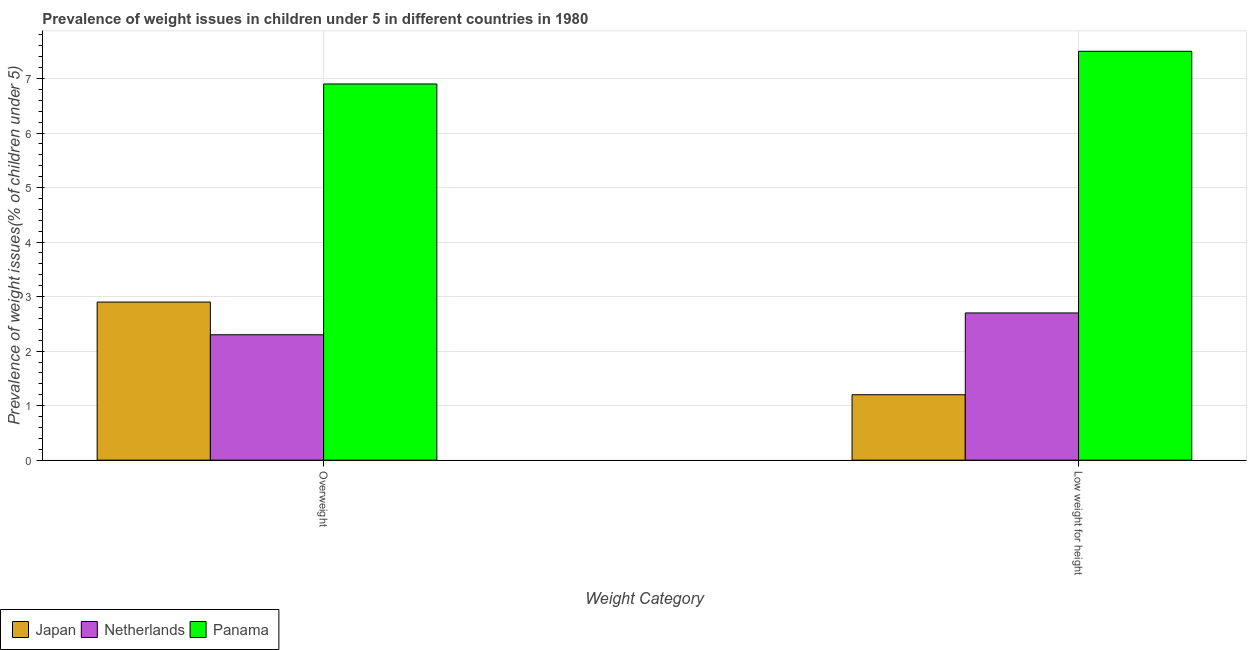Are the number of bars per tick equal to the number of legend labels?
Offer a very short reply. Yes. Are the number of bars on each tick of the X-axis equal?
Ensure brevity in your answer.  Yes. How many bars are there on the 1st tick from the right?
Provide a short and direct response. 3. What is the label of the 2nd group of bars from the left?
Offer a very short reply. Low weight for height. What is the percentage of underweight children in Japan?
Your response must be concise. 1.2. Across all countries, what is the maximum percentage of underweight children?
Keep it short and to the point. 7.5. Across all countries, what is the minimum percentage of overweight children?
Your answer should be compact. 2.3. In which country was the percentage of overweight children maximum?
Offer a very short reply. Panama. What is the total percentage of underweight children in the graph?
Ensure brevity in your answer.  11.4. What is the difference between the percentage of overweight children in Netherlands and that in Japan?
Ensure brevity in your answer.  -0.6. What is the difference between the percentage of underweight children in Japan and the percentage of overweight children in Panama?
Provide a short and direct response. -5.7. What is the average percentage of underweight children per country?
Provide a short and direct response. 3.8. What is the difference between the percentage of overweight children and percentage of underweight children in Panama?
Make the answer very short. -0.6. In how many countries, is the percentage of overweight children greater than 3.4 %?
Provide a succinct answer. 1. What is the ratio of the percentage of underweight children in Japan to that in Netherlands?
Ensure brevity in your answer.  0.44. What does the 3rd bar from the left in Low weight for height represents?
Your response must be concise. Panama. What does the 3rd bar from the right in Low weight for height represents?
Offer a terse response. Japan. How many bars are there?
Your answer should be compact. 6. Does the graph contain any zero values?
Ensure brevity in your answer.  No. Does the graph contain grids?
Offer a terse response. Yes. Where does the legend appear in the graph?
Keep it short and to the point. Bottom left. How many legend labels are there?
Offer a terse response. 3. What is the title of the graph?
Provide a short and direct response. Prevalence of weight issues in children under 5 in different countries in 1980. Does "Solomon Islands" appear as one of the legend labels in the graph?
Ensure brevity in your answer.  No. What is the label or title of the X-axis?
Give a very brief answer. Weight Category. What is the label or title of the Y-axis?
Provide a succinct answer. Prevalence of weight issues(% of children under 5). What is the Prevalence of weight issues(% of children under 5) in Japan in Overweight?
Offer a very short reply. 2.9. What is the Prevalence of weight issues(% of children under 5) in Netherlands in Overweight?
Your answer should be very brief. 2.3. What is the Prevalence of weight issues(% of children under 5) in Panama in Overweight?
Your response must be concise. 6.9. What is the Prevalence of weight issues(% of children under 5) in Japan in Low weight for height?
Offer a very short reply. 1.2. What is the Prevalence of weight issues(% of children under 5) of Netherlands in Low weight for height?
Ensure brevity in your answer.  2.7. Across all Weight Category, what is the maximum Prevalence of weight issues(% of children under 5) of Japan?
Give a very brief answer. 2.9. Across all Weight Category, what is the maximum Prevalence of weight issues(% of children under 5) in Netherlands?
Provide a short and direct response. 2.7. Across all Weight Category, what is the minimum Prevalence of weight issues(% of children under 5) in Japan?
Your response must be concise. 1.2. Across all Weight Category, what is the minimum Prevalence of weight issues(% of children under 5) of Netherlands?
Provide a short and direct response. 2.3. Across all Weight Category, what is the minimum Prevalence of weight issues(% of children under 5) of Panama?
Offer a very short reply. 6.9. What is the total Prevalence of weight issues(% of children under 5) of Japan in the graph?
Ensure brevity in your answer.  4.1. What is the total Prevalence of weight issues(% of children under 5) of Netherlands in the graph?
Make the answer very short. 5. What is the difference between the Prevalence of weight issues(% of children under 5) of Japan in Overweight and that in Low weight for height?
Offer a terse response. 1.7. What is the difference between the Prevalence of weight issues(% of children under 5) of Panama in Overweight and that in Low weight for height?
Your answer should be compact. -0.6. What is the difference between the Prevalence of weight issues(% of children under 5) in Japan in Overweight and the Prevalence of weight issues(% of children under 5) in Netherlands in Low weight for height?
Your response must be concise. 0.2. What is the difference between the Prevalence of weight issues(% of children under 5) in Japan in Overweight and the Prevalence of weight issues(% of children under 5) in Panama in Low weight for height?
Your answer should be very brief. -4.6. What is the difference between the Prevalence of weight issues(% of children under 5) of Netherlands in Overweight and the Prevalence of weight issues(% of children under 5) of Panama in Low weight for height?
Your response must be concise. -5.2. What is the average Prevalence of weight issues(% of children under 5) of Japan per Weight Category?
Give a very brief answer. 2.05. What is the difference between the Prevalence of weight issues(% of children under 5) of Japan and Prevalence of weight issues(% of children under 5) of Panama in Low weight for height?
Provide a short and direct response. -6.3. What is the ratio of the Prevalence of weight issues(% of children under 5) in Japan in Overweight to that in Low weight for height?
Ensure brevity in your answer.  2.42. What is the ratio of the Prevalence of weight issues(% of children under 5) in Netherlands in Overweight to that in Low weight for height?
Give a very brief answer. 0.85. What is the difference between the highest and the second highest Prevalence of weight issues(% of children under 5) of Netherlands?
Your response must be concise. 0.4. What is the difference between the highest and the second highest Prevalence of weight issues(% of children under 5) in Panama?
Make the answer very short. 0.6. What is the difference between the highest and the lowest Prevalence of weight issues(% of children under 5) of Netherlands?
Make the answer very short. 0.4. What is the difference between the highest and the lowest Prevalence of weight issues(% of children under 5) of Panama?
Provide a succinct answer. 0.6. 